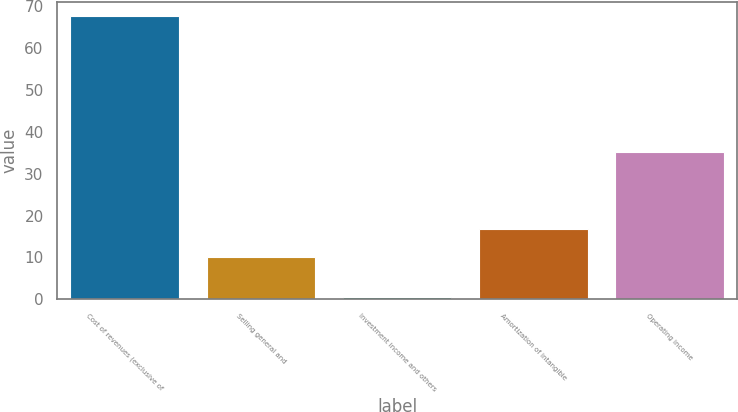Convert chart to OTSL. <chart><loc_0><loc_0><loc_500><loc_500><bar_chart><fcel>Cost of revenues (exclusive of<fcel>Selling general and<fcel>Investment income and others<fcel>Amortization of intangible<fcel>Operating income<nl><fcel>67.7<fcel>10.1<fcel>0.6<fcel>16.81<fcel>35.1<nl></chart> 